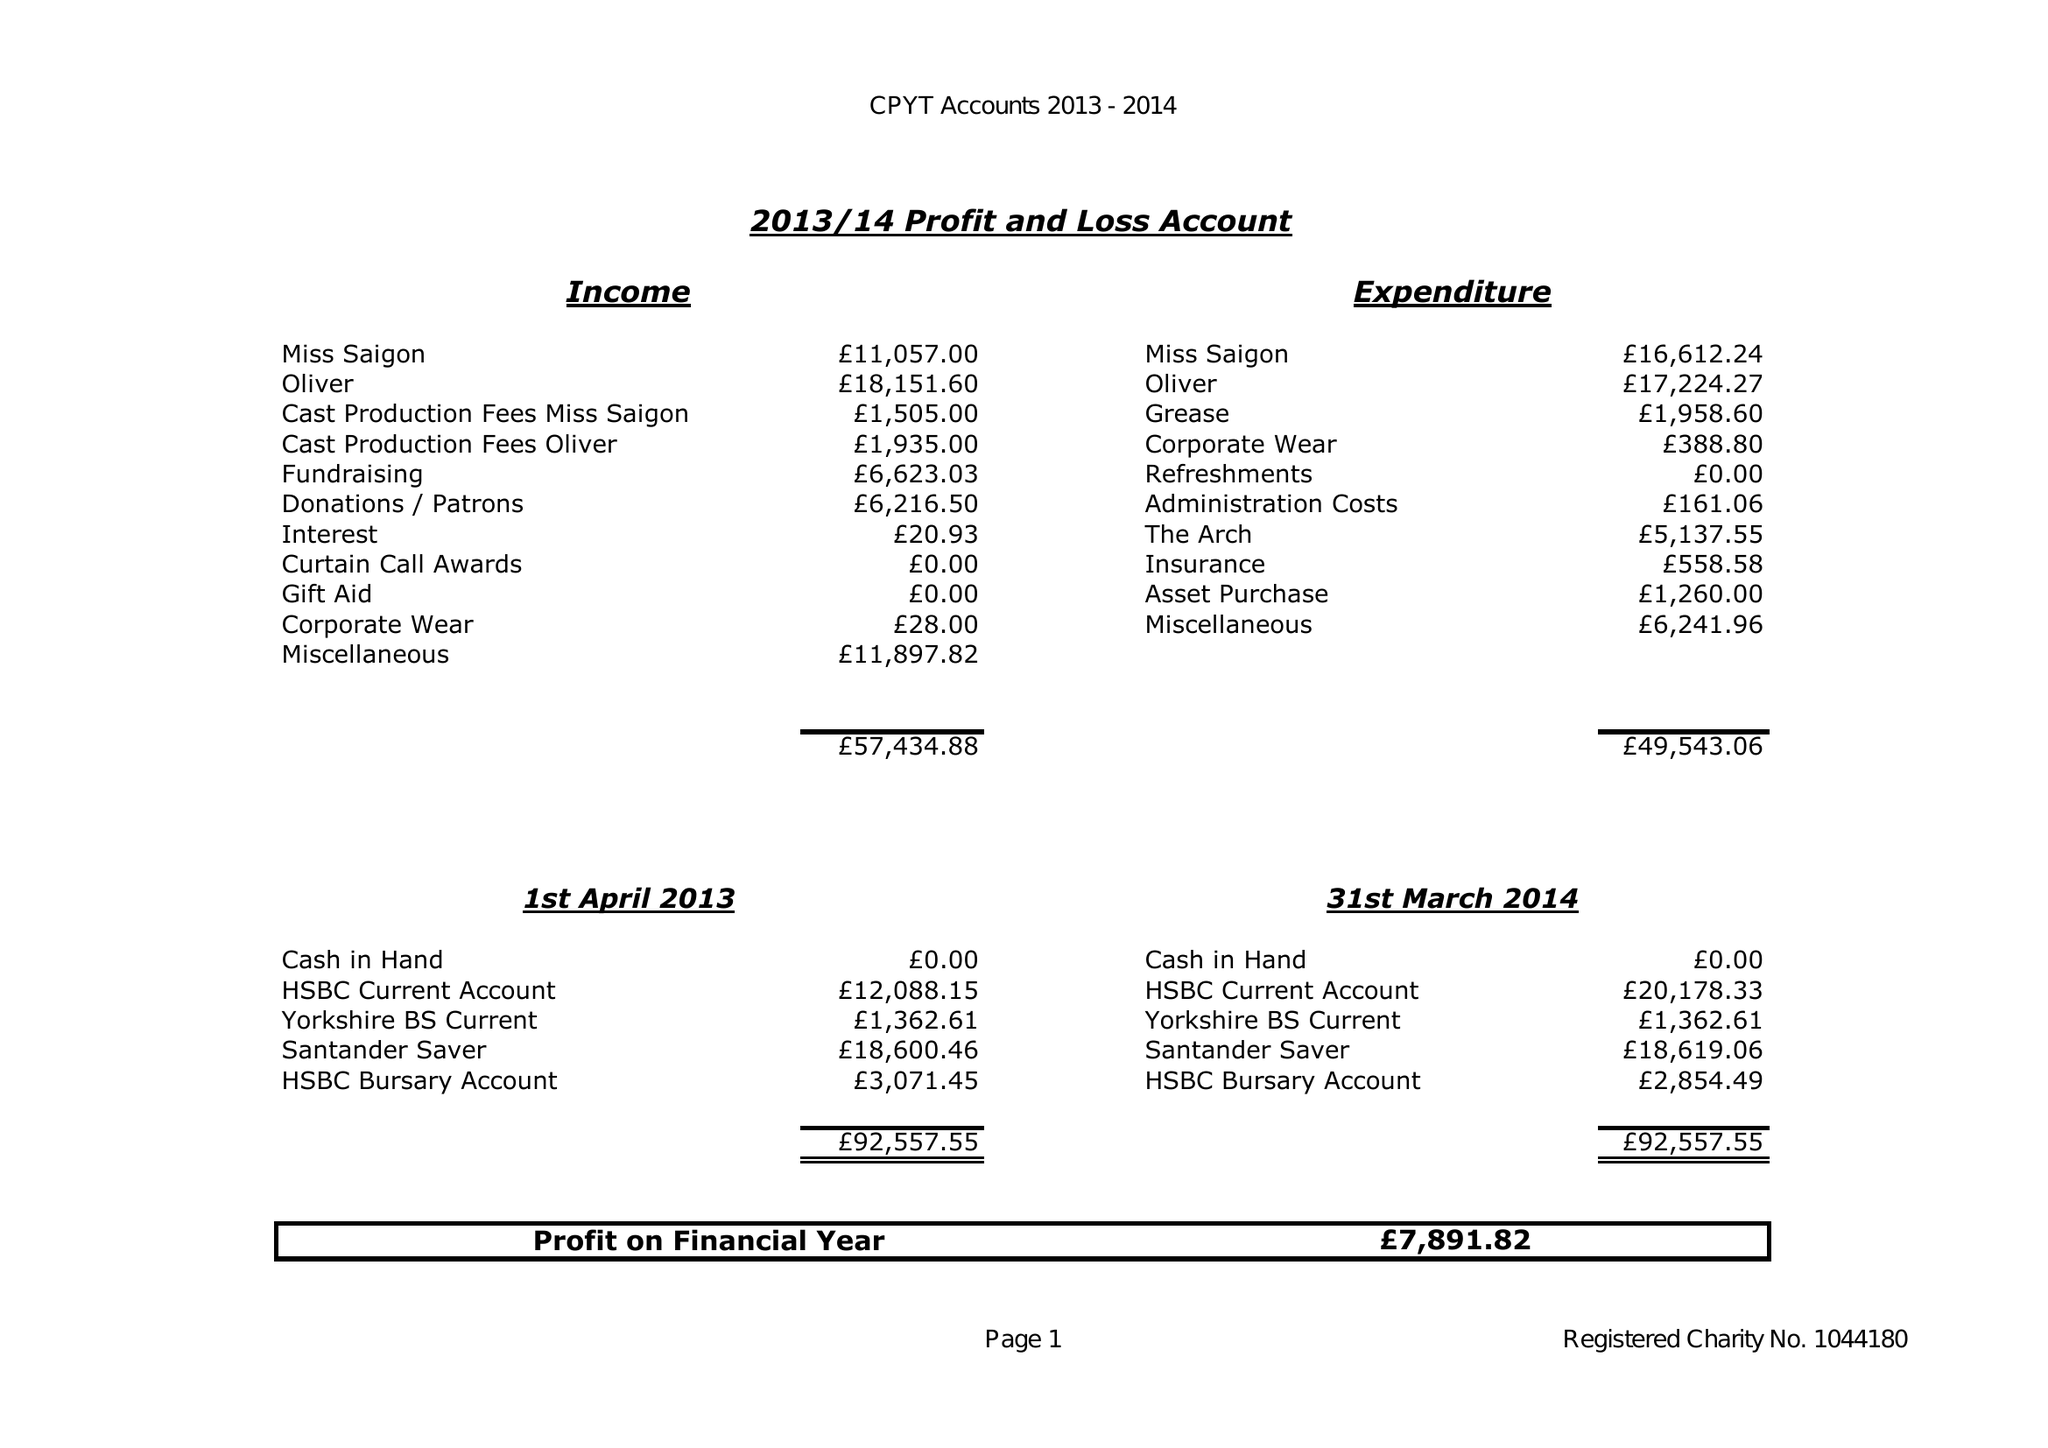What is the value for the address__street_line?
Answer the question using a single word or phrase. None 